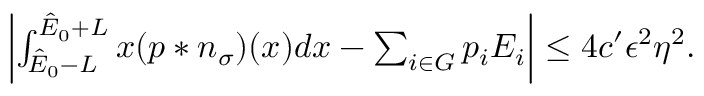<formula> <loc_0><loc_0><loc_500><loc_500>\begin{array} { r } { \left | \int _ { \hat { E } _ { 0 } - L } ^ { \hat { E } _ { 0 } + L } x ( p \ast n _ { \sigma } ) ( x ) d x - \sum _ { i \in G } p _ { i } E _ { i } \right | \leq 4 c ^ { \prime } \epsilon ^ { 2 } \eta ^ { 2 } . } \end{array}</formula> 